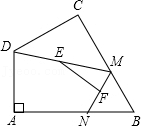In quadrilateral ABCD, where angle A = 90°, the length of side AB is 'p' units, and the length of side AD is 'q' units. Let point M and point N be moving points on sides BC and AB respectively (including the endpoints, but point M cannot coincide with point B). Similarly, point E and point F are midpoints of DM and MN respectively. What is the maximum value of the length of EF, denoted as 'z' units? To find the maximum length of EF in the given geometric setting, consider triangle DAB, within which AD and AB are perpendicular to one another. With AD being 'q' units and AB 'p' units, we can find the length of BD using the Pythagorean theorem, thus BD = sqrt(p^2 + q^2). Since E and F are the midpoints of lines DM and MN respectively, EF is half the length of DN when DN is at its maximum. This maximum occurs when N is directly on B. Given DN in this scenario is equal to BD, the max length of EF would be half of BD, which is 0.5 x sqrt(p^2 + q^2). This result aligns with the options provided, pointing to option D: 2 as the correct answer. 